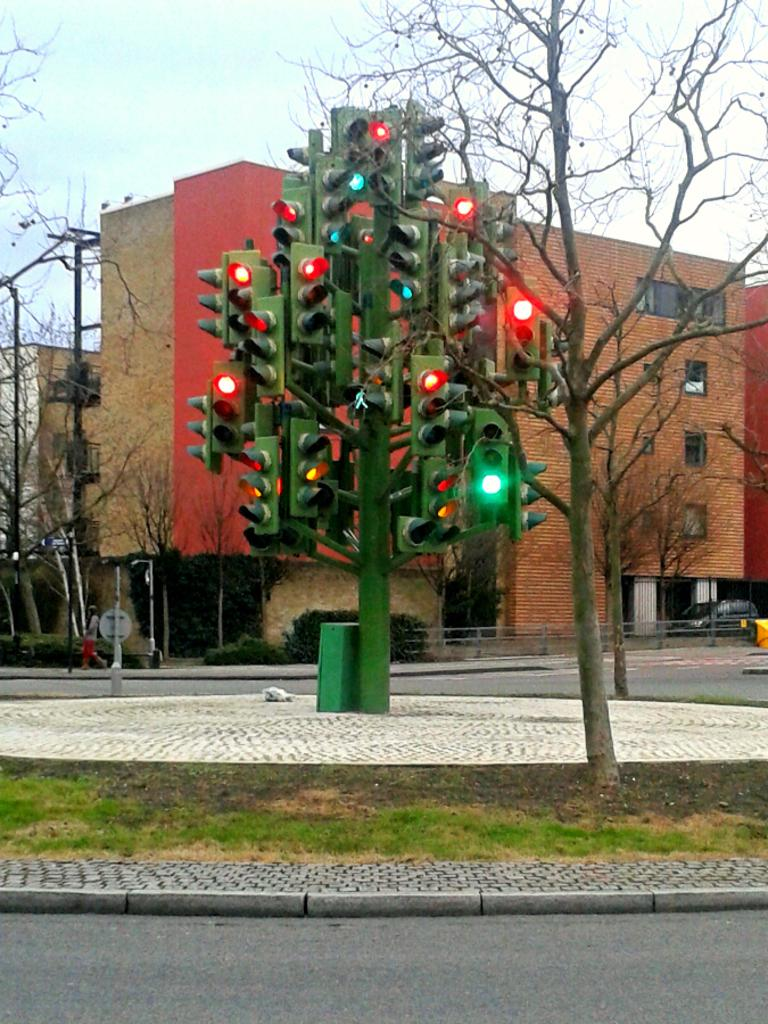What type of structures can be seen in the image? There are buildings in the image. What helps control traffic in the image? There are traffic lights in the image. What type of vegetation is present in the image? There are trees in the image. What might be used for safety or support in the image? There are railings in the image. Can you describe any other objects visible in the image? There are other objects in the image, but their specific details are not mentioned in the provided facts. What type of skirt is being worn by the traffic light in the image? There are no people or clothing items present in the image, including a skirt. The traffic light is an inanimate object and does not wear clothing. 